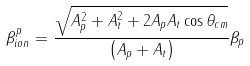Convert formula to latex. <formula><loc_0><loc_0><loc_500><loc_500>\beta _ { i o n } ^ { p } = \frac { \sqrt { A _ { p } ^ { 2 } + A _ { t } ^ { 2 } + 2 A _ { p } A _ { t } \cos \theta _ { c m } } } { \left ( A _ { p } + A _ { t } \right ) } \beta _ { p }</formula> 